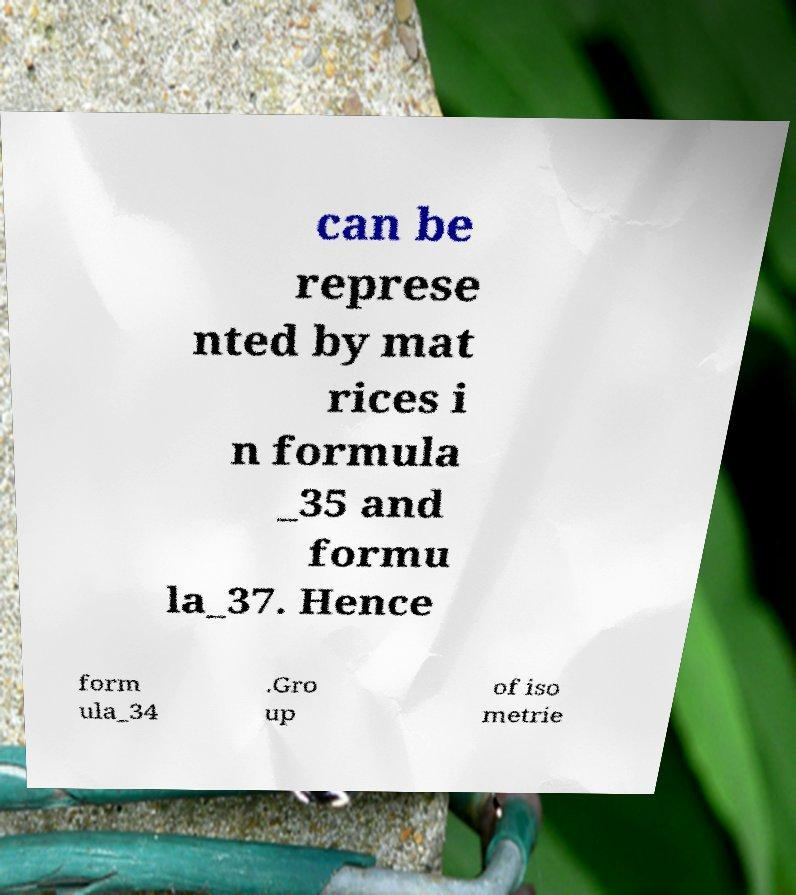Please read and relay the text visible in this image. What does it say? can be represe nted by mat rices i n formula _35 and formu la_37. Hence form ula_34 .Gro up of iso metrie 